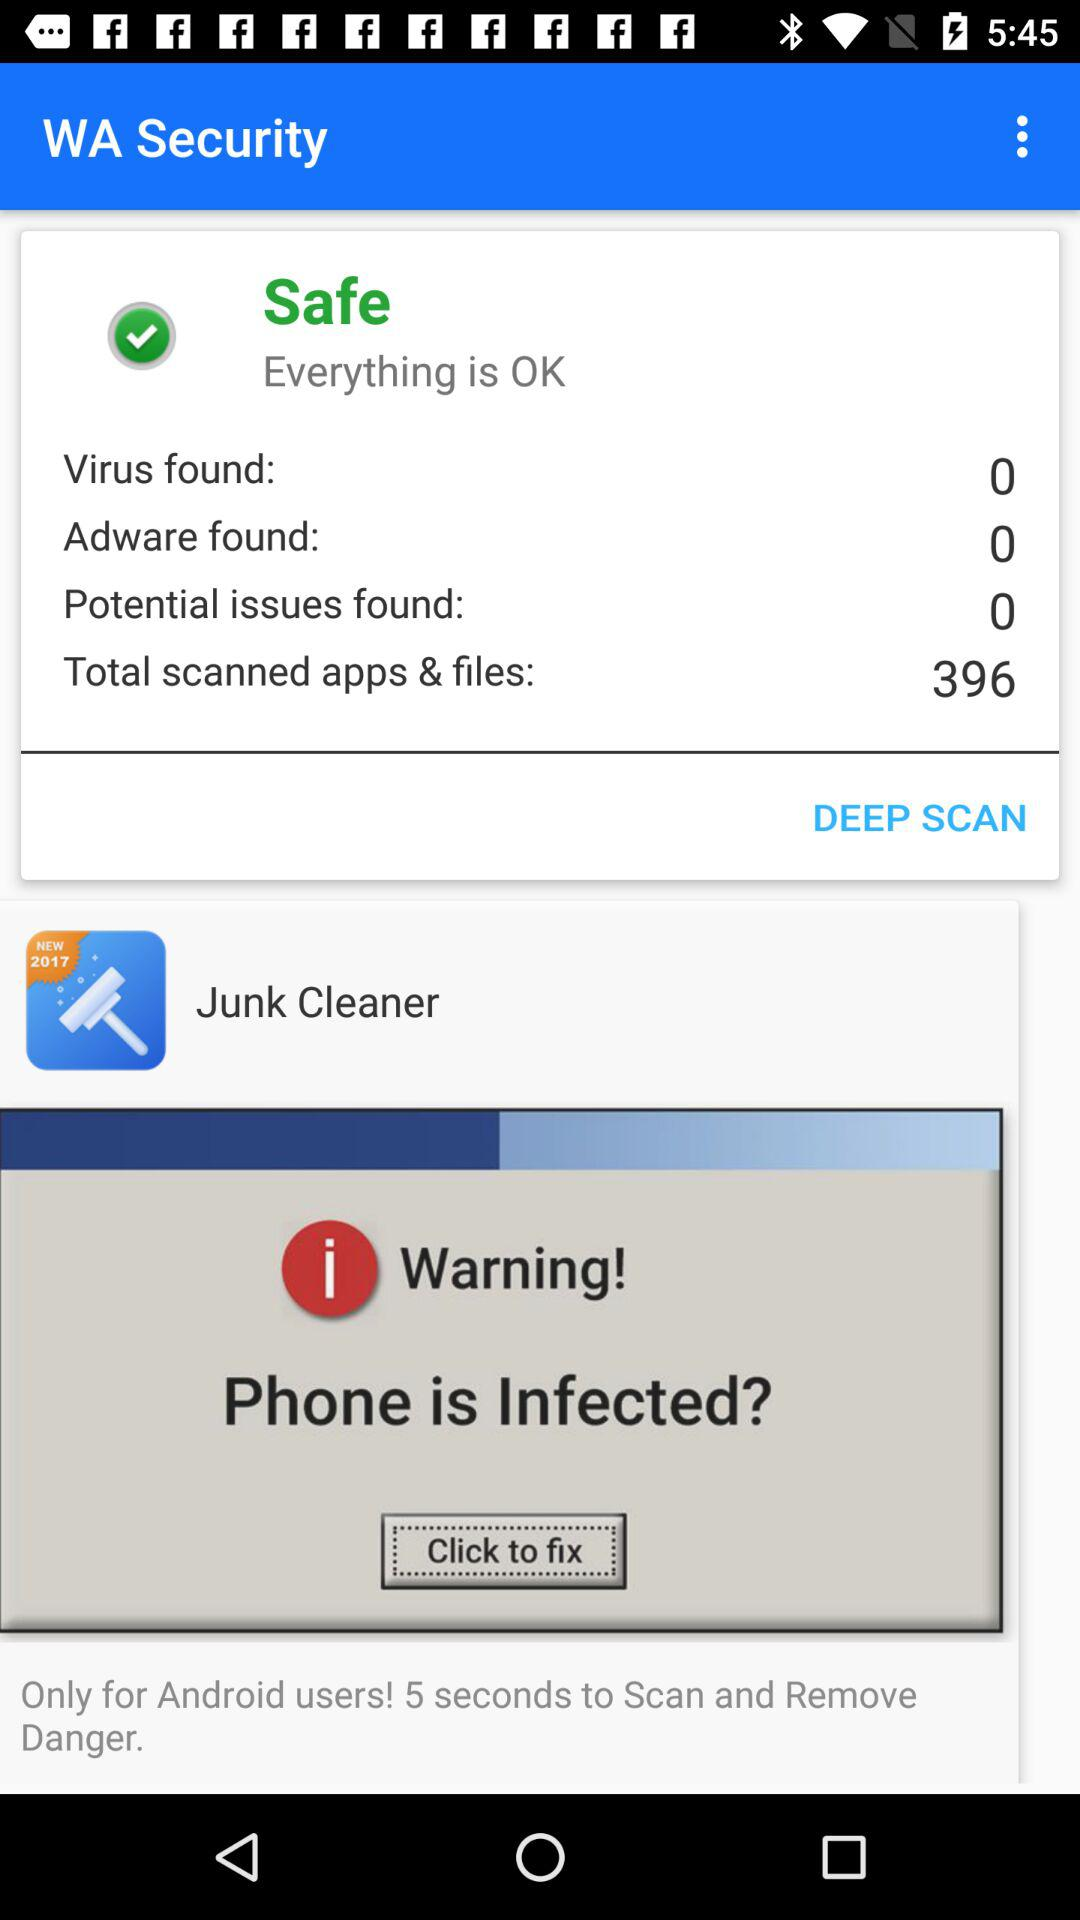What is the application name? The application name is "WA Security". 